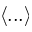<formula> <loc_0><loc_0><loc_500><loc_500>\langle \dots \rangle</formula> 